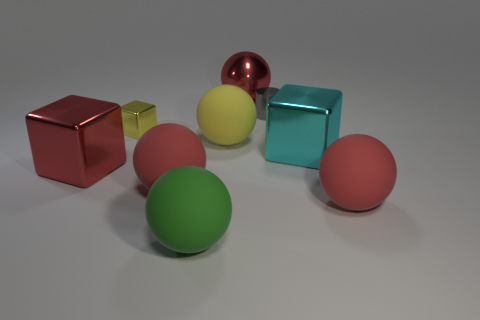There is a sphere that is right of the large red object behind the tiny yellow metal object; what is its material?
Your response must be concise. Rubber. How many big objects are both on the left side of the large cyan metal cube and in front of the big cyan shiny block?
Provide a short and direct response. 3. What number of other objects are the same size as the cyan metallic block?
Offer a terse response. 6. There is a green rubber object in front of the gray metal object; is it the same shape as the small thing to the left of the big yellow object?
Keep it short and to the point. No. Are there any tiny gray cylinders behind the large cyan shiny object?
Your response must be concise. Yes. What is the color of the small metallic thing that is the same shape as the large cyan shiny thing?
Your response must be concise. Yellow. Are there any other things that are the same shape as the green matte thing?
Ensure brevity in your answer.  Yes. What material is the cube behind the large cyan cube?
Make the answer very short. Metal. There is a red shiny object that is the same shape as the large green matte thing; what size is it?
Your response must be concise. Large. How many other large objects are the same material as the large green object?
Your answer should be compact. 3. 